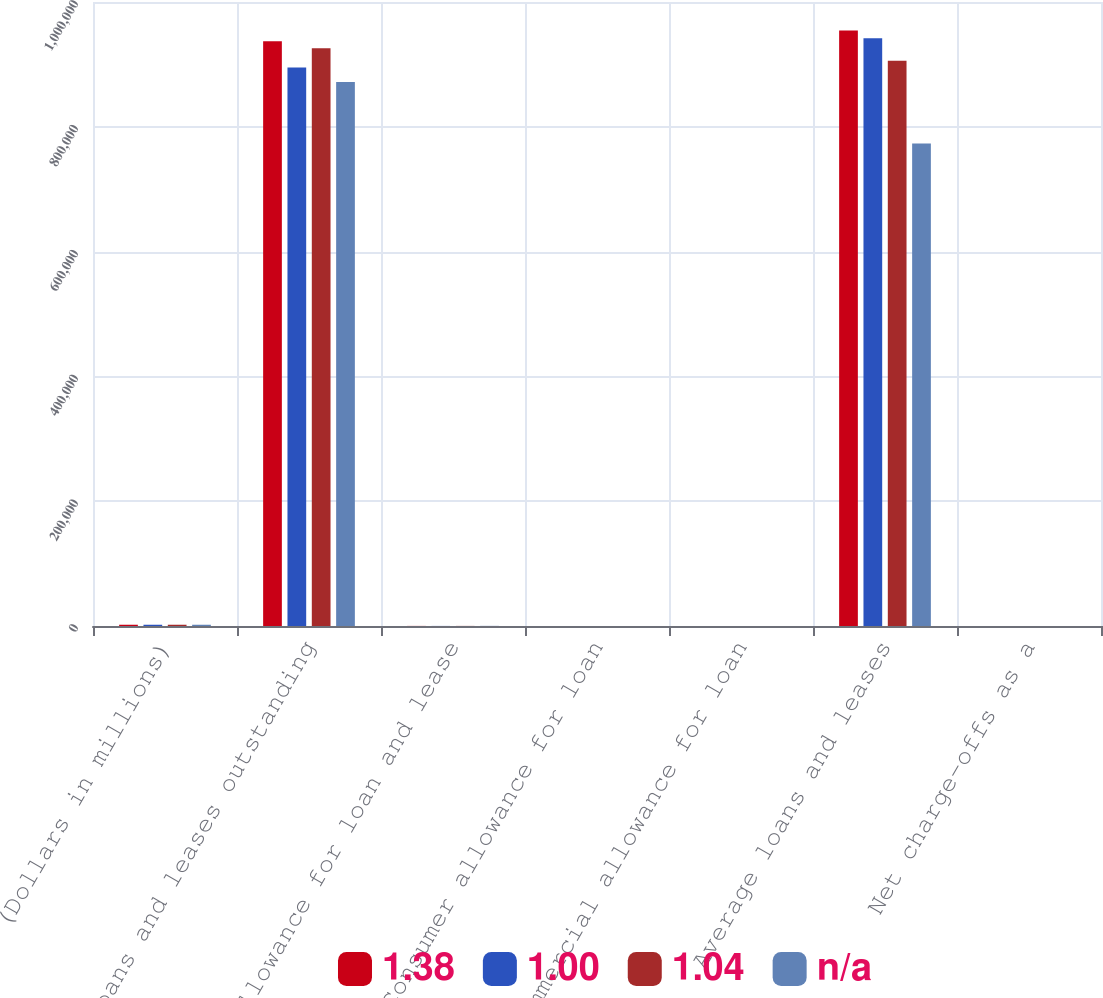<chart> <loc_0><loc_0><loc_500><loc_500><stacked_bar_chart><ecel><fcel>(Dollars in millions)<fcel>Loans and leases outstanding<fcel>Allowance for loan and lease<fcel>Consumer allowance for loan<fcel>Commercial allowance for loan<fcel>Average loans and leases<fcel>Net charge-offs as a<nl><fcel>1.38<fcel>2010<fcel>937119<fcel>136<fcel>5.4<fcel>2.44<fcel>954278<fcel>3.6<nl><fcel>1<fcel>2009<fcel>895192<fcel>111<fcel>4.81<fcel>2.96<fcel>941862<fcel>3.58<nl><fcel>1.04<fcel>2008<fcel>926033<fcel>141<fcel>2.83<fcel>1.9<fcel>905944<fcel>1.79<nl><fcel>nan<fcel>2007<fcel>871754<fcel>207<fcel>1.23<fcel>1.51<fcel>773142<fcel>0.84<nl></chart> 